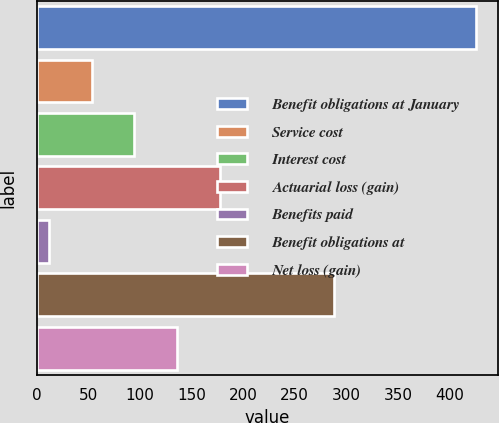Convert chart. <chart><loc_0><loc_0><loc_500><loc_500><bar_chart><fcel>Benefit obligations at January<fcel>Service cost<fcel>Interest cost<fcel>Actuarial loss (gain)<fcel>Benefits paid<fcel>Benefit obligations at<fcel>Net loss (gain)<nl><fcel>426<fcel>53.4<fcel>94.8<fcel>177.6<fcel>12<fcel>288<fcel>136.2<nl></chart> 